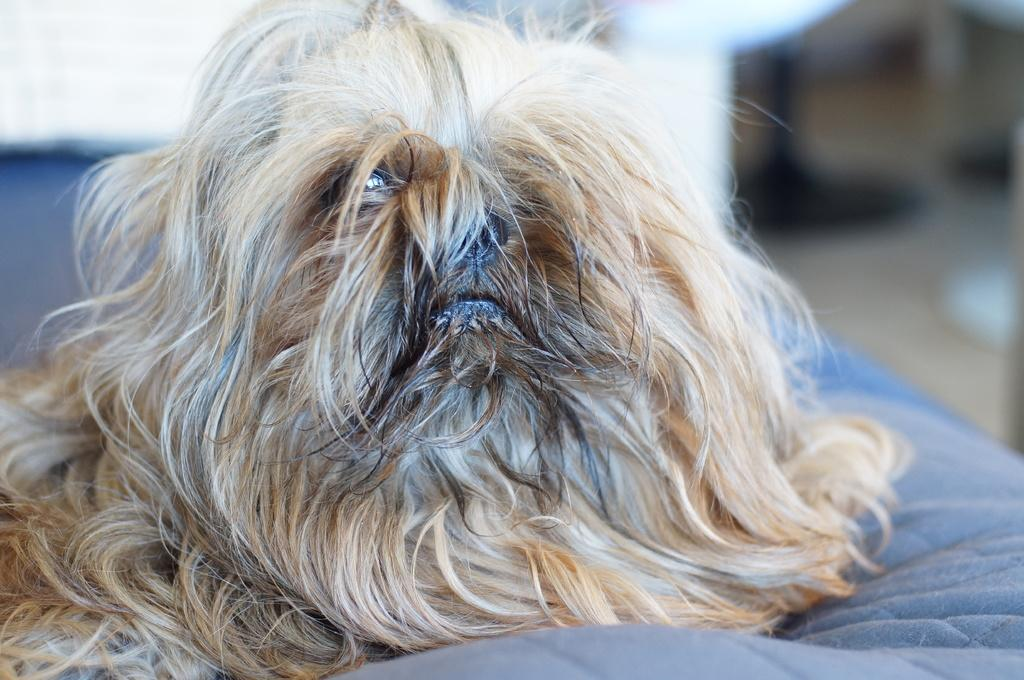What is the main subject in the foreground of the image? There is a dog in the foreground of the image. What object can be seen in the image besides the dog? There is a bed in the image. Can you describe the background of the image? The background of the image is blurry. What type of shirt is the dog wearing in the image? There is no shirt present on the dog in the image. 